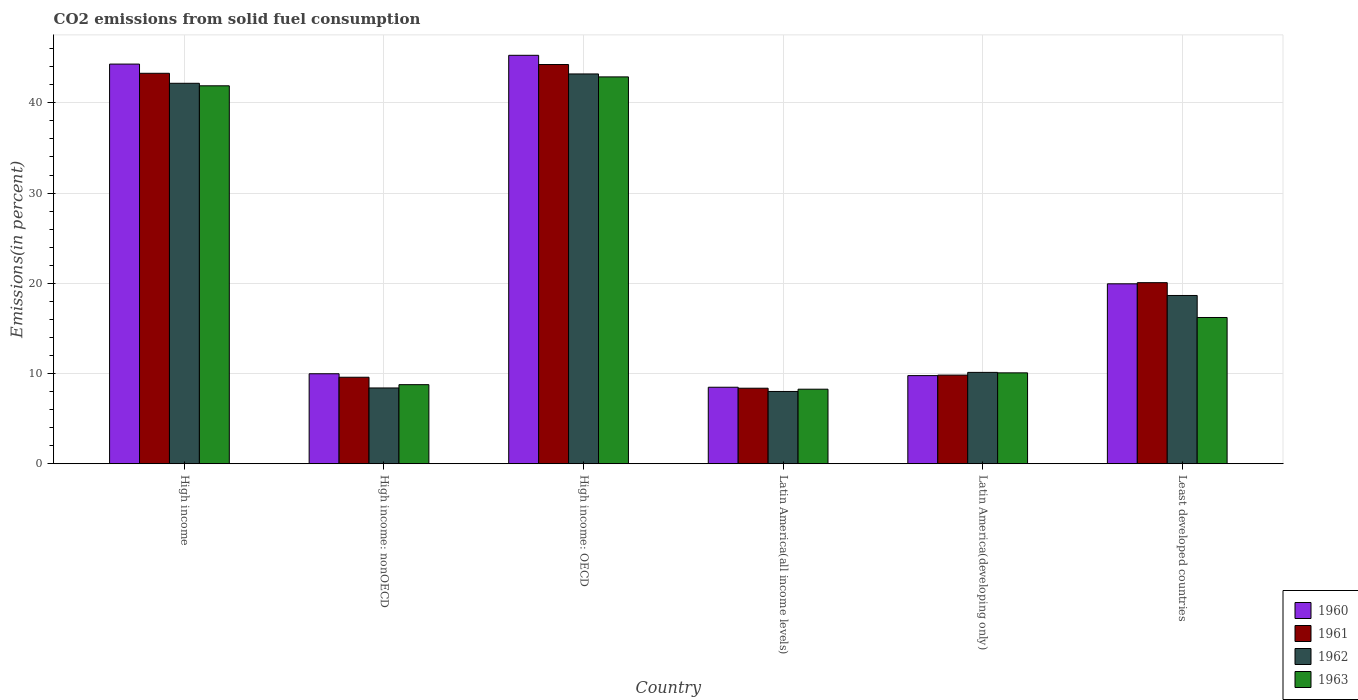How many groups of bars are there?
Your answer should be very brief. 6. Are the number of bars per tick equal to the number of legend labels?
Ensure brevity in your answer.  Yes. What is the label of the 4th group of bars from the left?
Offer a very short reply. Latin America(all income levels). What is the total CO2 emitted in 1961 in High income: nonOECD?
Provide a short and direct response. 9.59. Across all countries, what is the maximum total CO2 emitted in 1961?
Make the answer very short. 44.25. Across all countries, what is the minimum total CO2 emitted in 1960?
Provide a succinct answer. 8.48. In which country was the total CO2 emitted in 1963 maximum?
Provide a succinct answer. High income: OECD. In which country was the total CO2 emitted in 1963 minimum?
Your answer should be very brief. Latin America(all income levels). What is the total total CO2 emitted in 1961 in the graph?
Provide a short and direct response. 135.38. What is the difference between the total CO2 emitted in 1963 in Latin America(all income levels) and that in Latin America(developing only)?
Your answer should be compact. -1.81. What is the difference between the total CO2 emitted in 1961 in Latin America(developing only) and the total CO2 emitted in 1963 in High income: OECD?
Provide a succinct answer. -33.05. What is the average total CO2 emitted in 1960 per country?
Offer a very short reply. 22.95. What is the difference between the total CO2 emitted of/in 1960 and total CO2 emitted of/in 1962 in Latin America(developing only)?
Provide a succinct answer. -0.36. In how many countries, is the total CO2 emitted in 1960 greater than 18 %?
Offer a terse response. 3. What is the ratio of the total CO2 emitted in 1963 in Latin America(all income levels) to that in Least developed countries?
Give a very brief answer. 0.51. Is the total CO2 emitted in 1963 in High income less than that in Least developed countries?
Your response must be concise. No. Is the difference between the total CO2 emitted in 1960 in High income: OECD and Latin America(developing only) greater than the difference between the total CO2 emitted in 1962 in High income: OECD and Latin America(developing only)?
Your response must be concise. Yes. What is the difference between the highest and the second highest total CO2 emitted in 1963?
Offer a terse response. -25.68. What is the difference between the highest and the lowest total CO2 emitted in 1963?
Provide a succinct answer. 34.61. Is the sum of the total CO2 emitted in 1962 in Latin America(all income levels) and Least developed countries greater than the maximum total CO2 emitted in 1961 across all countries?
Offer a very short reply. No. Is it the case that in every country, the sum of the total CO2 emitted in 1961 and total CO2 emitted in 1962 is greater than the sum of total CO2 emitted in 1963 and total CO2 emitted in 1960?
Your answer should be compact. No. Is it the case that in every country, the sum of the total CO2 emitted in 1960 and total CO2 emitted in 1961 is greater than the total CO2 emitted in 1963?
Ensure brevity in your answer.  Yes. Are all the bars in the graph horizontal?
Make the answer very short. No. What is the title of the graph?
Your response must be concise. CO2 emissions from solid fuel consumption. What is the label or title of the X-axis?
Give a very brief answer. Country. What is the label or title of the Y-axis?
Your answer should be compact. Emissions(in percent). What is the Emissions(in percent) of 1960 in High income?
Offer a very short reply. 44.3. What is the Emissions(in percent) of 1961 in High income?
Give a very brief answer. 43.28. What is the Emissions(in percent) in 1962 in High income?
Give a very brief answer. 42.17. What is the Emissions(in percent) in 1963 in High income?
Ensure brevity in your answer.  41.89. What is the Emissions(in percent) in 1960 in High income: nonOECD?
Provide a short and direct response. 9.97. What is the Emissions(in percent) in 1961 in High income: nonOECD?
Provide a short and direct response. 9.59. What is the Emissions(in percent) of 1962 in High income: nonOECD?
Offer a terse response. 8.4. What is the Emissions(in percent) in 1963 in High income: nonOECD?
Provide a succinct answer. 8.76. What is the Emissions(in percent) in 1960 in High income: OECD?
Your answer should be compact. 45.27. What is the Emissions(in percent) of 1961 in High income: OECD?
Make the answer very short. 44.25. What is the Emissions(in percent) of 1962 in High income: OECD?
Your answer should be very brief. 43.2. What is the Emissions(in percent) of 1963 in High income: OECD?
Your answer should be compact. 42.88. What is the Emissions(in percent) in 1960 in Latin America(all income levels)?
Make the answer very short. 8.48. What is the Emissions(in percent) of 1961 in Latin America(all income levels)?
Offer a very short reply. 8.37. What is the Emissions(in percent) in 1962 in Latin America(all income levels)?
Keep it short and to the point. 8.01. What is the Emissions(in percent) in 1963 in Latin America(all income levels)?
Offer a terse response. 8.26. What is the Emissions(in percent) of 1960 in Latin America(developing only)?
Offer a terse response. 9.77. What is the Emissions(in percent) of 1961 in Latin America(developing only)?
Offer a very short reply. 9.82. What is the Emissions(in percent) of 1962 in Latin America(developing only)?
Ensure brevity in your answer.  10.13. What is the Emissions(in percent) of 1963 in Latin America(developing only)?
Your answer should be very brief. 10.07. What is the Emissions(in percent) in 1960 in Least developed countries?
Offer a very short reply. 19.94. What is the Emissions(in percent) of 1961 in Least developed countries?
Provide a short and direct response. 20.07. What is the Emissions(in percent) in 1962 in Least developed countries?
Your answer should be compact. 18.65. What is the Emissions(in percent) of 1963 in Least developed countries?
Your answer should be very brief. 16.21. Across all countries, what is the maximum Emissions(in percent) of 1960?
Give a very brief answer. 45.27. Across all countries, what is the maximum Emissions(in percent) of 1961?
Give a very brief answer. 44.25. Across all countries, what is the maximum Emissions(in percent) in 1962?
Offer a very short reply. 43.2. Across all countries, what is the maximum Emissions(in percent) in 1963?
Make the answer very short. 42.88. Across all countries, what is the minimum Emissions(in percent) of 1960?
Keep it short and to the point. 8.48. Across all countries, what is the minimum Emissions(in percent) in 1961?
Offer a very short reply. 8.37. Across all countries, what is the minimum Emissions(in percent) in 1962?
Your response must be concise. 8.01. Across all countries, what is the minimum Emissions(in percent) in 1963?
Your answer should be compact. 8.26. What is the total Emissions(in percent) of 1960 in the graph?
Keep it short and to the point. 137.73. What is the total Emissions(in percent) of 1961 in the graph?
Your response must be concise. 135.38. What is the total Emissions(in percent) in 1962 in the graph?
Make the answer very short. 130.55. What is the total Emissions(in percent) in 1963 in the graph?
Make the answer very short. 128.07. What is the difference between the Emissions(in percent) in 1960 in High income and that in High income: nonOECD?
Ensure brevity in your answer.  34.32. What is the difference between the Emissions(in percent) of 1961 in High income and that in High income: nonOECD?
Keep it short and to the point. 33.69. What is the difference between the Emissions(in percent) of 1962 in High income and that in High income: nonOECD?
Keep it short and to the point. 33.77. What is the difference between the Emissions(in percent) of 1963 in High income and that in High income: nonOECD?
Provide a succinct answer. 33.12. What is the difference between the Emissions(in percent) in 1960 in High income and that in High income: OECD?
Make the answer very short. -0.97. What is the difference between the Emissions(in percent) in 1961 in High income and that in High income: OECD?
Your answer should be compact. -0.97. What is the difference between the Emissions(in percent) of 1962 in High income and that in High income: OECD?
Give a very brief answer. -1.04. What is the difference between the Emissions(in percent) in 1963 in High income and that in High income: OECD?
Ensure brevity in your answer.  -0.99. What is the difference between the Emissions(in percent) in 1960 in High income and that in Latin America(all income levels)?
Your answer should be compact. 35.82. What is the difference between the Emissions(in percent) of 1961 in High income and that in Latin America(all income levels)?
Your response must be concise. 34.9. What is the difference between the Emissions(in percent) in 1962 in High income and that in Latin America(all income levels)?
Offer a very short reply. 34.16. What is the difference between the Emissions(in percent) of 1963 in High income and that in Latin America(all income levels)?
Ensure brevity in your answer.  33.63. What is the difference between the Emissions(in percent) of 1960 in High income and that in Latin America(developing only)?
Your answer should be very brief. 34.53. What is the difference between the Emissions(in percent) in 1961 in High income and that in Latin America(developing only)?
Offer a terse response. 33.45. What is the difference between the Emissions(in percent) of 1962 in High income and that in Latin America(developing only)?
Your answer should be compact. 32.04. What is the difference between the Emissions(in percent) of 1963 in High income and that in Latin America(developing only)?
Keep it short and to the point. 31.81. What is the difference between the Emissions(in percent) of 1960 in High income and that in Least developed countries?
Provide a succinct answer. 24.36. What is the difference between the Emissions(in percent) of 1961 in High income and that in Least developed countries?
Give a very brief answer. 23.21. What is the difference between the Emissions(in percent) in 1962 in High income and that in Least developed countries?
Ensure brevity in your answer.  23.52. What is the difference between the Emissions(in percent) of 1963 in High income and that in Least developed countries?
Provide a succinct answer. 25.68. What is the difference between the Emissions(in percent) in 1960 in High income: nonOECD and that in High income: OECD?
Offer a very short reply. -35.3. What is the difference between the Emissions(in percent) in 1961 in High income: nonOECD and that in High income: OECD?
Your response must be concise. -34.66. What is the difference between the Emissions(in percent) of 1962 in High income: nonOECD and that in High income: OECD?
Your answer should be compact. -34.81. What is the difference between the Emissions(in percent) in 1963 in High income: nonOECD and that in High income: OECD?
Your response must be concise. -34.11. What is the difference between the Emissions(in percent) of 1960 in High income: nonOECD and that in Latin America(all income levels)?
Provide a short and direct response. 1.49. What is the difference between the Emissions(in percent) of 1961 in High income: nonOECD and that in Latin America(all income levels)?
Your answer should be very brief. 1.22. What is the difference between the Emissions(in percent) of 1962 in High income: nonOECD and that in Latin America(all income levels)?
Make the answer very short. 0.39. What is the difference between the Emissions(in percent) of 1963 in High income: nonOECD and that in Latin America(all income levels)?
Offer a terse response. 0.5. What is the difference between the Emissions(in percent) in 1960 in High income: nonOECD and that in Latin America(developing only)?
Ensure brevity in your answer.  0.21. What is the difference between the Emissions(in percent) in 1961 in High income: nonOECD and that in Latin America(developing only)?
Ensure brevity in your answer.  -0.24. What is the difference between the Emissions(in percent) in 1962 in High income: nonOECD and that in Latin America(developing only)?
Make the answer very short. -1.73. What is the difference between the Emissions(in percent) of 1963 in High income: nonOECD and that in Latin America(developing only)?
Your response must be concise. -1.31. What is the difference between the Emissions(in percent) in 1960 in High income: nonOECD and that in Least developed countries?
Your answer should be very brief. -9.97. What is the difference between the Emissions(in percent) in 1961 in High income: nonOECD and that in Least developed countries?
Make the answer very short. -10.48. What is the difference between the Emissions(in percent) in 1962 in High income: nonOECD and that in Least developed countries?
Offer a very short reply. -10.25. What is the difference between the Emissions(in percent) in 1963 in High income: nonOECD and that in Least developed countries?
Make the answer very short. -7.45. What is the difference between the Emissions(in percent) of 1960 in High income: OECD and that in Latin America(all income levels)?
Keep it short and to the point. 36.79. What is the difference between the Emissions(in percent) in 1961 in High income: OECD and that in Latin America(all income levels)?
Your answer should be compact. 35.88. What is the difference between the Emissions(in percent) in 1962 in High income: OECD and that in Latin America(all income levels)?
Keep it short and to the point. 35.19. What is the difference between the Emissions(in percent) in 1963 in High income: OECD and that in Latin America(all income levels)?
Offer a very short reply. 34.61. What is the difference between the Emissions(in percent) in 1960 in High income: OECD and that in Latin America(developing only)?
Make the answer very short. 35.5. What is the difference between the Emissions(in percent) in 1961 in High income: OECD and that in Latin America(developing only)?
Keep it short and to the point. 34.42. What is the difference between the Emissions(in percent) of 1962 in High income: OECD and that in Latin America(developing only)?
Ensure brevity in your answer.  33.08. What is the difference between the Emissions(in percent) of 1963 in High income: OECD and that in Latin America(developing only)?
Make the answer very short. 32.8. What is the difference between the Emissions(in percent) of 1960 in High income: OECD and that in Least developed countries?
Your answer should be compact. 25.33. What is the difference between the Emissions(in percent) of 1961 in High income: OECD and that in Least developed countries?
Provide a short and direct response. 24.18. What is the difference between the Emissions(in percent) in 1962 in High income: OECD and that in Least developed countries?
Your answer should be compact. 24.55. What is the difference between the Emissions(in percent) of 1963 in High income: OECD and that in Least developed countries?
Your answer should be very brief. 26.67. What is the difference between the Emissions(in percent) of 1960 in Latin America(all income levels) and that in Latin America(developing only)?
Provide a succinct answer. -1.29. What is the difference between the Emissions(in percent) in 1961 in Latin America(all income levels) and that in Latin America(developing only)?
Keep it short and to the point. -1.45. What is the difference between the Emissions(in percent) of 1962 in Latin America(all income levels) and that in Latin America(developing only)?
Offer a very short reply. -2.12. What is the difference between the Emissions(in percent) of 1963 in Latin America(all income levels) and that in Latin America(developing only)?
Provide a short and direct response. -1.81. What is the difference between the Emissions(in percent) in 1960 in Latin America(all income levels) and that in Least developed countries?
Provide a short and direct response. -11.46. What is the difference between the Emissions(in percent) in 1961 in Latin America(all income levels) and that in Least developed countries?
Your answer should be compact. -11.7. What is the difference between the Emissions(in percent) of 1962 in Latin America(all income levels) and that in Least developed countries?
Give a very brief answer. -10.64. What is the difference between the Emissions(in percent) of 1963 in Latin America(all income levels) and that in Least developed countries?
Keep it short and to the point. -7.95. What is the difference between the Emissions(in percent) of 1960 in Latin America(developing only) and that in Least developed countries?
Ensure brevity in your answer.  -10.17. What is the difference between the Emissions(in percent) in 1961 in Latin America(developing only) and that in Least developed countries?
Offer a terse response. -10.24. What is the difference between the Emissions(in percent) in 1962 in Latin America(developing only) and that in Least developed countries?
Your answer should be compact. -8.52. What is the difference between the Emissions(in percent) of 1963 in Latin America(developing only) and that in Least developed countries?
Provide a short and direct response. -6.14. What is the difference between the Emissions(in percent) of 1960 in High income and the Emissions(in percent) of 1961 in High income: nonOECD?
Keep it short and to the point. 34.71. What is the difference between the Emissions(in percent) of 1960 in High income and the Emissions(in percent) of 1962 in High income: nonOECD?
Ensure brevity in your answer.  35.9. What is the difference between the Emissions(in percent) in 1960 in High income and the Emissions(in percent) in 1963 in High income: nonOECD?
Offer a very short reply. 35.53. What is the difference between the Emissions(in percent) of 1961 in High income and the Emissions(in percent) of 1962 in High income: nonOECD?
Your answer should be compact. 34.88. What is the difference between the Emissions(in percent) of 1961 in High income and the Emissions(in percent) of 1963 in High income: nonOECD?
Ensure brevity in your answer.  34.51. What is the difference between the Emissions(in percent) in 1962 in High income and the Emissions(in percent) in 1963 in High income: nonOECD?
Offer a terse response. 33.4. What is the difference between the Emissions(in percent) in 1960 in High income and the Emissions(in percent) in 1961 in High income: OECD?
Make the answer very short. 0.05. What is the difference between the Emissions(in percent) in 1960 in High income and the Emissions(in percent) in 1962 in High income: OECD?
Provide a succinct answer. 1.09. What is the difference between the Emissions(in percent) of 1960 in High income and the Emissions(in percent) of 1963 in High income: OECD?
Your response must be concise. 1.42. What is the difference between the Emissions(in percent) in 1961 in High income and the Emissions(in percent) in 1962 in High income: OECD?
Ensure brevity in your answer.  0.07. What is the difference between the Emissions(in percent) in 1961 in High income and the Emissions(in percent) in 1963 in High income: OECD?
Ensure brevity in your answer.  0.4. What is the difference between the Emissions(in percent) in 1962 in High income and the Emissions(in percent) in 1963 in High income: OECD?
Ensure brevity in your answer.  -0.71. What is the difference between the Emissions(in percent) in 1960 in High income and the Emissions(in percent) in 1961 in Latin America(all income levels)?
Make the answer very short. 35.92. What is the difference between the Emissions(in percent) in 1960 in High income and the Emissions(in percent) in 1962 in Latin America(all income levels)?
Offer a terse response. 36.29. What is the difference between the Emissions(in percent) in 1960 in High income and the Emissions(in percent) in 1963 in Latin America(all income levels)?
Your response must be concise. 36.03. What is the difference between the Emissions(in percent) of 1961 in High income and the Emissions(in percent) of 1962 in Latin America(all income levels)?
Offer a terse response. 35.27. What is the difference between the Emissions(in percent) in 1961 in High income and the Emissions(in percent) in 1963 in Latin America(all income levels)?
Offer a terse response. 35.01. What is the difference between the Emissions(in percent) of 1962 in High income and the Emissions(in percent) of 1963 in Latin America(all income levels)?
Provide a short and direct response. 33.91. What is the difference between the Emissions(in percent) of 1960 in High income and the Emissions(in percent) of 1961 in Latin America(developing only)?
Make the answer very short. 34.47. What is the difference between the Emissions(in percent) of 1960 in High income and the Emissions(in percent) of 1962 in Latin America(developing only)?
Offer a terse response. 34.17. What is the difference between the Emissions(in percent) in 1960 in High income and the Emissions(in percent) in 1963 in Latin America(developing only)?
Ensure brevity in your answer.  34.22. What is the difference between the Emissions(in percent) in 1961 in High income and the Emissions(in percent) in 1962 in Latin America(developing only)?
Give a very brief answer. 33.15. What is the difference between the Emissions(in percent) in 1961 in High income and the Emissions(in percent) in 1963 in Latin America(developing only)?
Keep it short and to the point. 33.2. What is the difference between the Emissions(in percent) in 1962 in High income and the Emissions(in percent) in 1963 in Latin America(developing only)?
Offer a very short reply. 32.09. What is the difference between the Emissions(in percent) of 1960 in High income and the Emissions(in percent) of 1961 in Least developed countries?
Your answer should be very brief. 24.23. What is the difference between the Emissions(in percent) in 1960 in High income and the Emissions(in percent) in 1962 in Least developed countries?
Your answer should be compact. 25.65. What is the difference between the Emissions(in percent) in 1960 in High income and the Emissions(in percent) in 1963 in Least developed countries?
Ensure brevity in your answer.  28.09. What is the difference between the Emissions(in percent) in 1961 in High income and the Emissions(in percent) in 1962 in Least developed countries?
Ensure brevity in your answer.  24.63. What is the difference between the Emissions(in percent) of 1961 in High income and the Emissions(in percent) of 1963 in Least developed countries?
Provide a succinct answer. 27.07. What is the difference between the Emissions(in percent) of 1962 in High income and the Emissions(in percent) of 1963 in Least developed countries?
Offer a terse response. 25.96. What is the difference between the Emissions(in percent) of 1960 in High income: nonOECD and the Emissions(in percent) of 1961 in High income: OECD?
Give a very brief answer. -34.27. What is the difference between the Emissions(in percent) in 1960 in High income: nonOECD and the Emissions(in percent) in 1962 in High income: OECD?
Provide a succinct answer. -33.23. What is the difference between the Emissions(in percent) of 1960 in High income: nonOECD and the Emissions(in percent) of 1963 in High income: OECD?
Your response must be concise. -32.9. What is the difference between the Emissions(in percent) of 1961 in High income: nonOECD and the Emissions(in percent) of 1962 in High income: OECD?
Keep it short and to the point. -33.62. What is the difference between the Emissions(in percent) in 1961 in High income: nonOECD and the Emissions(in percent) in 1963 in High income: OECD?
Make the answer very short. -33.29. What is the difference between the Emissions(in percent) in 1962 in High income: nonOECD and the Emissions(in percent) in 1963 in High income: OECD?
Your answer should be very brief. -34.48. What is the difference between the Emissions(in percent) of 1960 in High income: nonOECD and the Emissions(in percent) of 1961 in Latin America(all income levels)?
Your response must be concise. 1.6. What is the difference between the Emissions(in percent) of 1960 in High income: nonOECD and the Emissions(in percent) of 1962 in Latin America(all income levels)?
Keep it short and to the point. 1.96. What is the difference between the Emissions(in percent) in 1960 in High income: nonOECD and the Emissions(in percent) in 1963 in Latin America(all income levels)?
Your response must be concise. 1.71. What is the difference between the Emissions(in percent) of 1961 in High income: nonOECD and the Emissions(in percent) of 1962 in Latin America(all income levels)?
Your answer should be very brief. 1.58. What is the difference between the Emissions(in percent) of 1961 in High income: nonOECD and the Emissions(in percent) of 1963 in Latin America(all income levels)?
Keep it short and to the point. 1.32. What is the difference between the Emissions(in percent) in 1962 in High income: nonOECD and the Emissions(in percent) in 1963 in Latin America(all income levels)?
Offer a very short reply. 0.14. What is the difference between the Emissions(in percent) of 1960 in High income: nonOECD and the Emissions(in percent) of 1961 in Latin America(developing only)?
Make the answer very short. 0.15. What is the difference between the Emissions(in percent) in 1960 in High income: nonOECD and the Emissions(in percent) in 1962 in Latin America(developing only)?
Your answer should be compact. -0.15. What is the difference between the Emissions(in percent) of 1960 in High income: nonOECD and the Emissions(in percent) of 1963 in Latin America(developing only)?
Ensure brevity in your answer.  -0.1. What is the difference between the Emissions(in percent) of 1961 in High income: nonOECD and the Emissions(in percent) of 1962 in Latin America(developing only)?
Keep it short and to the point. -0.54. What is the difference between the Emissions(in percent) of 1961 in High income: nonOECD and the Emissions(in percent) of 1963 in Latin America(developing only)?
Give a very brief answer. -0.49. What is the difference between the Emissions(in percent) in 1962 in High income: nonOECD and the Emissions(in percent) in 1963 in Latin America(developing only)?
Provide a short and direct response. -1.68. What is the difference between the Emissions(in percent) of 1960 in High income: nonOECD and the Emissions(in percent) of 1961 in Least developed countries?
Give a very brief answer. -10.1. What is the difference between the Emissions(in percent) in 1960 in High income: nonOECD and the Emissions(in percent) in 1962 in Least developed countries?
Ensure brevity in your answer.  -8.68. What is the difference between the Emissions(in percent) of 1960 in High income: nonOECD and the Emissions(in percent) of 1963 in Least developed countries?
Offer a very short reply. -6.24. What is the difference between the Emissions(in percent) of 1961 in High income: nonOECD and the Emissions(in percent) of 1962 in Least developed countries?
Keep it short and to the point. -9.06. What is the difference between the Emissions(in percent) in 1961 in High income: nonOECD and the Emissions(in percent) in 1963 in Least developed countries?
Provide a short and direct response. -6.62. What is the difference between the Emissions(in percent) of 1962 in High income: nonOECD and the Emissions(in percent) of 1963 in Least developed countries?
Offer a terse response. -7.81. What is the difference between the Emissions(in percent) of 1960 in High income: OECD and the Emissions(in percent) of 1961 in Latin America(all income levels)?
Your response must be concise. 36.9. What is the difference between the Emissions(in percent) in 1960 in High income: OECD and the Emissions(in percent) in 1962 in Latin America(all income levels)?
Ensure brevity in your answer.  37.26. What is the difference between the Emissions(in percent) of 1960 in High income: OECD and the Emissions(in percent) of 1963 in Latin America(all income levels)?
Offer a terse response. 37.01. What is the difference between the Emissions(in percent) of 1961 in High income: OECD and the Emissions(in percent) of 1962 in Latin America(all income levels)?
Your answer should be very brief. 36.24. What is the difference between the Emissions(in percent) of 1961 in High income: OECD and the Emissions(in percent) of 1963 in Latin America(all income levels)?
Your response must be concise. 35.99. What is the difference between the Emissions(in percent) in 1962 in High income: OECD and the Emissions(in percent) in 1963 in Latin America(all income levels)?
Provide a short and direct response. 34.94. What is the difference between the Emissions(in percent) of 1960 in High income: OECD and the Emissions(in percent) of 1961 in Latin America(developing only)?
Give a very brief answer. 35.45. What is the difference between the Emissions(in percent) of 1960 in High income: OECD and the Emissions(in percent) of 1962 in Latin America(developing only)?
Keep it short and to the point. 35.14. What is the difference between the Emissions(in percent) in 1960 in High income: OECD and the Emissions(in percent) in 1963 in Latin America(developing only)?
Make the answer very short. 35.2. What is the difference between the Emissions(in percent) of 1961 in High income: OECD and the Emissions(in percent) of 1962 in Latin America(developing only)?
Keep it short and to the point. 34.12. What is the difference between the Emissions(in percent) in 1961 in High income: OECD and the Emissions(in percent) in 1963 in Latin America(developing only)?
Offer a very short reply. 34.17. What is the difference between the Emissions(in percent) of 1962 in High income: OECD and the Emissions(in percent) of 1963 in Latin America(developing only)?
Keep it short and to the point. 33.13. What is the difference between the Emissions(in percent) in 1960 in High income: OECD and the Emissions(in percent) in 1961 in Least developed countries?
Provide a succinct answer. 25.2. What is the difference between the Emissions(in percent) of 1960 in High income: OECD and the Emissions(in percent) of 1962 in Least developed countries?
Provide a succinct answer. 26.62. What is the difference between the Emissions(in percent) in 1960 in High income: OECD and the Emissions(in percent) in 1963 in Least developed countries?
Ensure brevity in your answer.  29.06. What is the difference between the Emissions(in percent) of 1961 in High income: OECD and the Emissions(in percent) of 1962 in Least developed countries?
Your answer should be very brief. 25.6. What is the difference between the Emissions(in percent) in 1961 in High income: OECD and the Emissions(in percent) in 1963 in Least developed countries?
Your response must be concise. 28.04. What is the difference between the Emissions(in percent) of 1962 in High income: OECD and the Emissions(in percent) of 1963 in Least developed countries?
Make the answer very short. 26.99. What is the difference between the Emissions(in percent) in 1960 in Latin America(all income levels) and the Emissions(in percent) in 1961 in Latin America(developing only)?
Offer a terse response. -1.35. What is the difference between the Emissions(in percent) of 1960 in Latin America(all income levels) and the Emissions(in percent) of 1962 in Latin America(developing only)?
Make the answer very short. -1.65. What is the difference between the Emissions(in percent) in 1960 in Latin America(all income levels) and the Emissions(in percent) in 1963 in Latin America(developing only)?
Keep it short and to the point. -1.6. What is the difference between the Emissions(in percent) of 1961 in Latin America(all income levels) and the Emissions(in percent) of 1962 in Latin America(developing only)?
Your answer should be very brief. -1.75. What is the difference between the Emissions(in percent) of 1961 in Latin America(all income levels) and the Emissions(in percent) of 1963 in Latin America(developing only)?
Your response must be concise. -1.7. What is the difference between the Emissions(in percent) in 1962 in Latin America(all income levels) and the Emissions(in percent) in 1963 in Latin America(developing only)?
Make the answer very short. -2.06. What is the difference between the Emissions(in percent) in 1960 in Latin America(all income levels) and the Emissions(in percent) in 1961 in Least developed countries?
Ensure brevity in your answer.  -11.59. What is the difference between the Emissions(in percent) of 1960 in Latin America(all income levels) and the Emissions(in percent) of 1962 in Least developed countries?
Ensure brevity in your answer.  -10.17. What is the difference between the Emissions(in percent) of 1960 in Latin America(all income levels) and the Emissions(in percent) of 1963 in Least developed countries?
Ensure brevity in your answer.  -7.73. What is the difference between the Emissions(in percent) of 1961 in Latin America(all income levels) and the Emissions(in percent) of 1962 in Least developed countries?
Offer a terse response. -10.28. What is the difference between the Emissions(in percent) in 1961 in Latin America(all income levels) and the Emissions(in percent) in 1963 in Least developed countries?
Make the answer very short. -7.84. What is the difference between the Emissions(in percent) of 1962 in Latin America(all income levels) and the Emissions(in percent) of 1963 in Least developed countries?
Make the answer very short. -8.2. What is the difference between the Emissions(in percent) of 1960 in Latin America(developing only) and the Emissions(in percent) of 1961 in Least developed countries?
Give a very brief answer. -10.3. What is the difference between the Emissions(in percent) of 1960 in Latin America(developing only) and the Emissions(in percent) of 1962 in Least developed countries?
Offer a terse response. -8.88. What is the difference between the Emissions(in percent) of 1960 in Latin America(developing only) and the Emissions(in percent) of 1963 in Least developed countries?
Your answer should be compact. -6.44. What is the difference between the Emissions(in percent) in 1961 in Latin America(developing only) and the Emissions(in percent) in 1962 in Least developed countries?
Provide a succinct answer. -8.82. What is the difference between the Emissions(in percent) of 1961 in Latin America(developing only) and the Emissions(in percent) of 1963 in Least developed countries?
Your response must be concise. -6.39. What is the difference between the Emissions(in percent) in 1962 in Latin America(developing only) and the Emissions(in percent) in 1963 in Least developed countries?
Provide a short and direct response. -6.08. What is the average Emissions(in percent) in 1960 per country?
Keep it short and to the point. 22.95. What is the average Emissions(in percent) of 1961 per country?
Give a very brief answer. 22.56. What is the average Emissions(in percent) in 1962 per country?
Your answer should be very brief. 21.76. What is the average Emissions(in percent) in 1963 per country?
Provide a short and direct response. 21.35. What is the difference between the Emissions(in percent) in 1960 and Emissions(in percent) in 1961 in High income?
Your answer should be compact. 1.02. What is the difference between the Emissions(in percent) in 1960 and Emissions(in percent) in 1962 in High income?
Your answer should be compact. 2.13. What is the difference between the Emissions(in percent) of 1960 and Emissions(in percent) of 1963 in High income?
Offer a terse response. 2.41. What is the difference between the Emissions(in percent) in 1961 and Emissions(in percent) in 1962 in High income?
Offer a very short reply. 1.11. What is the difference between the Emissions(in percent) in 1961 and Emissions(in percent) in 1963 in High income?
Ensure brevity in your answer.  1.39. What is the difference between the Emissions(in percent) of 1962 and Emissions(in percent) of 1963 in High income?
Your answer should be compact. 0.28. What is the difference between the Emissions(in percent) in 1960 and Emissions(in percent) in 1961 in High income: nonOECD?
Ensure brevity in your answer.  0.39. What is the difference between the Emissions(in percent) in 1960 and Emissions(in percent) in 1962 in High income: nonOECD?
Provide a short and direct response. 1.57. What is the difference between the Emissions(in percent) of 1960 and Emissions(in percent) of 1963 in High income: nonOECD?
Provide a succinct answer. 1.21. What is the difference between the Emissions(in percent) of 1961 and Emissions(in percent) of 1962 in High income: nonOECD?
Keep it short and to the point. 1.19. What is the difference between the Emissions(in percent) in 1961 and Emissions(in percent) in 1963 in High income: nonOECD?
Your answer should be very brief. 0.82. What is the difference between the Emissions(in percent) of 1962 and Emissions(in percent) of 1963 in High income: nonOECD?
Your answer should be compact. -0.37. What is the difference between the Emissions(in percent) of 1960 and Emissions(in percent) of 1961 in High income: OECD?
Offer a terse response. 1.02. What is the difference between the Emissions(in percent) in 1960 and Emissions(in percent) in 1962 in High income: OECD?
Offer a very short reply. 2.07. What is the difference between the Emissions(in percent) in 1960 and Emissions(in percent) in 1963 in High income: OECD?
Your answer should be very brief. 2.39. What is the difference between the Emissions(in percent) in 1961 and Emissions(in percent) in 1962 in High income: OECD?
Provide a short and direct response. 1.04. What is the difference between the Emissions(in percent) of 1961 and Emissions(in percent) of 1963 in High income: OECD?
Your answer should be very brief. 1.37. What is the difference between the Emissions(in percent) of 1962 and Emissions(in percent) of 1963 in High income: OECD?
Make the answer very short. 0.33. What is the difference between the Emissions(in percent) of 1960 and Emissions(in percent) of 1961 in Latin America(all income levels)?
Your response must be concise. 0.11. What is the difference between the Emissions(in percent) in 1960 and Emissions(in percent) in 1962 in Latin America(all income levels)?
Provide a short and direct response. 0.47. What is the difference between the Emissions(in percent) of 1960 and Emissions(in percent) of 1963 in Latin America(all income levels)?
Provide a succinct answer. 0.22. What is the difference between the Emissions(in percent) of 1961 and Emissions(in percent) of 1962 in Latin America(all income levels)?
Your response must be concise. 0.36. What is the difference between the Emissions(in percent) in 1961 and Emissions(in percent) in 1963 in Latin America(all income levels)?
Give a very brief answer. 0.11. What is the difference between the Emissions(in percent) in 1962 and Emissions(in percent) in 1963 in Latin America(all income levels)?
Make the answer very short. -0.25. What is the difference between the Emissions(in percent) in 1960 and Emissions(in percent) in 1961 in Latin America(developing only)?
Keep it short and to the point. -0.06. What is the difference between the Emissions(in percent) in 1960 and Emissions(in percent) in 1962 in Latin America(developing only)?
Your answer should be compact. -0.36. What is the difference between the Emissions(in percent) of 1960 and Emissions(in percent) of 1963 in Latin America(developing only)?
Ensure brevity in your answer.  -0.31. What is the difference between the Emissions(in percent) in 1961 and Emissions(in percent) in 1962 in Latin America(developing only)?
Your answer should be very brief. -0.3. What is the difference between the Emissions(in percent) of 1961 and Emissions(in percent) of 1963 in Latin America(developing only)?
Provide a short and direct response. -0.25. What is the difference between the Emissions(in percent) in 1962 and Emissions(in percent) in 1963 in Latin America(developing only)?
Your answer should be very brief. 0.05. What is the difference between the Emissions(in percent) in 1960 and Emissions(in percent) in 1961 in Least developed countries?
Your answer should be very brief. -0.13. What is the difference between the Emissions(in percent) of 1960 and Emissions(in percent) of 1962 in Least developed countries?
Ensure brevity in your answer.  1.29. What is the difference between the Emissions(in percent) in 1960 and Emissions(in percent) in 1963 in Least developed countries?
Make the answer very short. 3.73. What is the difference between the Emissions(in percent) of 1961 and Emissions(in percent) of 1962 in Least developed countries?
Keep it short and to the point. 1.42. What is the difference between the Emissions(in percent) in 1961 and Emissions(in percent) in 1963 in Least developed countries?
Ensure brevity in your answer.  3.86. What is the difference between the Emissions(in percent) in 1962 and Emissions(in percent) in 1963 in Least developed countries?
Provide a short and direct response. 2.44. What is the ratio of the Emissions(in percent) of 1960 in High income to that in High income: nonOECD?
Provide a short and direct response. 4.44. What is the ratio of the Emissions(in percent) of 1961 in High income to that in High income: nonOECD?
Offer a terse response. 4.51. What is the ratio of the Emissions(in percent) in 1962 in High income to that in High income: nonOECD?
Your answer should be very brief. 5.02. What is the ratio of the Emissions(in percent) in 1963 in High income to that in High income: nonOECD?
Your answer should be compact. 4.78. What is the ratio of the Emissions(in percent) of 1960 in High income to that in High income: OECD?
Make the answer very short. 0.98. What is the ratio of the Emissions(in percent) of 1962 in High income to that in High income: OECD?
Your response must be concise. 0.98. What is the ratio of the Emissions(in percent) of 1963 in High income to that in High income: OECD?
Your answer should be very brief. 0.98. What is the ratio of the Emissions(in percent) of 1960 in High income to that in Latin America(all income levels)?
Provide a succinct answer. 5.22. What is the ratio of the Emissions(in percent) in 1961 in High income to that in Latin America(all income levels)?
Offer a terse response. 5.17. What is the ratio of the Emissions(in percent) of 1962 in High income to that in Latin America(all income levels)?
Give a very brief answer. 5.26. What is the ratio of the Emissions(in percent) in 1963 in High income to that in Latin America(all income levels)?
Offer a terse response. 5.07. What is the ratio of the Emissions(in percent) in 1960 in High income to that in Latin America(developing only)?
Offer a very short reply. 4.54. What is the ratio of the Emissions(in percent) in 1961 in High income to that in Latin America(developing only)?
Offer a terse response. 4.4. What is the ratio of the Emissions(in percent) of 1962 in High income to that in Latin America(developing only)?
Make the answer very short. 4.16. What is the ratio of the Emissions(in percent) of 1963 in High income to that in Latin America(developing only)?
Your answer should be very brief. 4.16. What is the ratio of the Emissions(in percent) in 1960 in High income to that in Least developed countries?
Offer a very short reply. 2.22. What is the ratio of the Emissions(in percent) of 1961 in High income to that in Least developed countries?
Your answer should be compact. 2.16. What is the ratio of the Emissions(in percent) in 1962 in High income to that in Least developed countries?
Keep it short and to the point. 2.26. What is the ratio of the Emissions(in percent) of 1963 in High income to that in Least developed countries?
Your response must be concise. 2.58. What is the ratio of the Emissions(in percent) of 1960 in High income: nonOECD to that in High income: OECD?
Your answer should be compact. 0.22. What is the ratio of the Emissions(in percent) in 1961 in High income: nonOECD to that in High income: OECD?
Your response must be concise. 0.22. What is the ratio of the Emissions(in percent) in 1962 in High income: nonOECD to that in High income: OECD?
Ensure brevity in your answer.  0.19. What is the ratio of the Emissions(in percent) in 1963 in High income: nonOECD to that in High income: OECD?
Give a very brief answer. 0.2. What is the ratio of the Emissions(in percent) of 1960 in High income: nonOECD to that in Latin America(all income levels)?
Make the answer very short. 1.18. What is the ratio of the Emissions(in percent) in 1961 in High income: nonOECD to that in Latin America(all income levels)?
Give a very brief answer. 1.15. What is the ratio of the Emissions(in percent) of 1962 in High income: nonOECD to that in Latin America(all income levels)?
Keep it short and to the point. 1.05. What is the ratio of the Emissions(in percent) in 1963 in High income: nonOECD to that in Latin America(all income levels)?
Provide a succinct answer. 1.06. What is the ratio of the Emissions(in percent) in 1960 in High income: nonOECD to that in Latin America(developing only)?
Your response must be concise. 1.02. What is the ratio of the Emissions(in percent) in 1961 in High income: nonOECD to that in Latin America(developing only)?
Offer a very short reply. 0.98. What is the ratio of the Emissions(in percent) of 1962 in High income: nonOECD to that in Latin America(developing only)?
Offer a very short reply. 0.83. What is the ratio of the Emissions(in percent) in 1963 in High income: nonOECD to that in Latin America(developing only)?
Ensure brevity in your answer.  0.87. What is the ratio of the Emissions(in percent) of 1960 in High income: nonOECD to that in Least developed countries?
Keep it short and to the point. 0.5. What is the ratio of the Emissions(in percent) in 1961 in High income: nonOECD to that in Least developed countries?
Offer a terse response. 0.48. What is the ratio of the Emissions(in percent) in 1962 in High income: nonOECD to that in Least developed countries?
Your answer should be compact. 0.45. What is the ratio of the Emissions(in percent) in 1963 in High income: nonOECD to that in Least developed countries?
Make the answer very short. 0.54. What is the ratio of the Emissions(in percent) of 1960 in High income: OECD to that in Latin America(all income levels)?
Offer a terse response. 5.34. What is the ratio of the Emissions(in percent) of 1961 in High income: OECD to that in Latin America(all income levels)?
Offer a terse response. 5.29. What is the ratio of the Emissions(in percent) of 1962 in High income: OECD to that in Latin America(all income levels)?
Keep it short and to the point. 5.39. What is the ratio of the Emissions(in percent) of 1963 in High income: OECD to that in Latin America(all income levels)?
Ensure brevity in your answer.  5.19. What is the ratio of the Emissions(in percent) of 1960 in High income: OECD to that in Latin America(developing only)?
Keep it short and to the point. 4.63. What is the ratio of the Emissions(in percent) in 1961 in High income: OECD to that in Latin America(developing only)?
Your answer should be compact. 4.5. What is the ratio of the Emissions(in percent) of 1962 in High income: OECD to that in Latin America(developing only)?
Ensure brevity in your answer.  4.27. What is the ratio of the Emissions(in percent) in 1963 in High income: OECD to that in Latin America(developing only)?
Your answer should be compact. 4.26. What is the ratio of the Emissions(in percent) of 1960 in High income: OECD to that in Least developed countries?
Ensure brevity in your answer.  2.27. What is the ratio of the Emissions(in percent) of 1961 in High income: OECD to that in Least developed countries?
Your answer should be compact. 2.2. What is the ratio of the Emissions(in percent) in 1962 in High income: OECD to that in Least developed countries?
Offer a terse response. 2.32. What is the ratio of the Emissions(in percent) of 1963 in High income: OECD to that in Least developed countries?
Your answer should be compact. 2.65. What is the ratio of the Emissions(in percent) in 1960 in Latin America(all income levels) to that in Latin America(developing only)?
Make the answer very short. 0.87. What is the ratio of the Emissions(in percent) of 1961 in Latin America(all income levels) to that in Latin America(developing only)?
Your answer should be very brief. 0.85. What is the ratio of the Emissions(in percent) of 1962 in Latin America(all income levels) to that in Latin America(developing only)?
Provide a short and direct response. 0.79. What is the ratio of the Emissions(in percent) in 1963 in Latin America(all income levels) to that in Latin America(developing only)?
Offer a terse response. 0.82. What is the ratio of the Emissions(in percent) of 1960 in Latin America(all income levels) to that in Least developed countries?
Your response must be concise. 0.43. What is the ratio of the Emissions(in percent) of 1961 in Latin America(all income levels) to that in Least developed countries?
Offer a terse response. 0.42. What is the ratio of the Emissions(in percent) in 1962 in Latin America(all income levels) to that in Least developed countries?
Make the answer very short. 0.43. What is the ratio of the Emissions(in percent) in 1963 in Latin America(all income levels) to that in Least developed countries?
Your response must be concise. 0.51. What is the ratio of the Emissions(in percent) of 1960 in Latin America(developing only) to that in Least developed countries?
Your answer should be compact. 0.49. What is the ratio of the Emissions(in percent) in 1961 in Latin America(developing only) to that in Least developed countries?
Provide a short and direct response. 0.49. What is the ratio of the Emissions(in percent) of 1962 in Latin America(developing only) to that in Least developed countries?
Your response must be concise. 0.54. What is the ratio of the Emissions(in percent) in 1963 in Latin America(developing only) to that in Least developed countries?
Your answer should be compact. 0.62. What is the difference between the highest and the second highest Emissions(in percent) of 1960?
Provide a short and direct response. 0.97. What is the difference between the highest and the second highest Emissions(in percent) of 1961?
Your answer should be compact. 0.97. What is the difference between the highest and the second highest Emissions(in percent) in 1962?
Your answer should be compact. 1.04. What is the difference between the highest and the lowest Emissions(in percent) in 1960?
Offer a terse response. 36.79. What is the difference between the highest and the lowest Emissions(in percent) of 1961?
Ensure brevity in your answer.  35.88. What is the difference between the highest and the lowest Emissions(in percent) of 1962?
Your response must be concise. 35.19. What is the difference between the highest and the lowest Emissions(in percent) of 1963?
Provide a succinct answer. 34.61. 